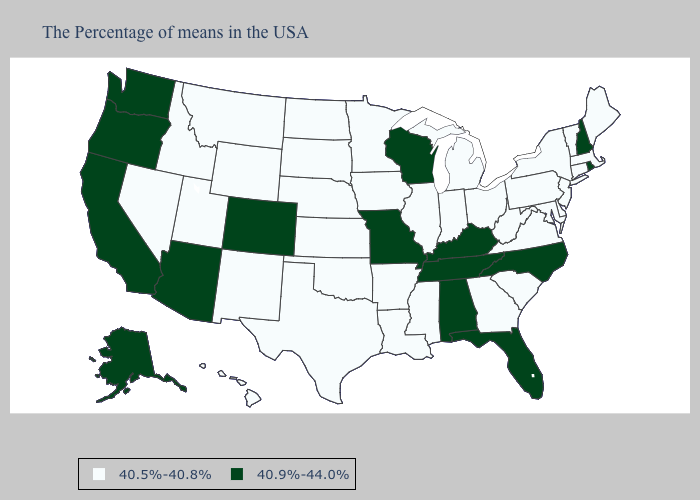What is the value of Kentucky?
Answer briefly. 40.9%-44.0%. Name the states that have a value in the range 40.5%-40.8%?
Quick response, please. Maine, Massachusetts, Vermont, Connecticut, New York, New Jersey, Delaware, Maryland, Pennsylvania, Virginia, South Carolina, West Virginia, Ohio, Georgia, Michigan, Indiana, Illinois, Mississippi, Louisiana, Arkansas, Minnesota, Iowa, Kansas, Nebraska, Oklahoma, Texas, South Dakota, North Dakota, Wyoming, New Mexico, Utah, Montana, Idaho, Nevada, Hawaii. What is the highest value in states that border New York?
Short answer required. 40.5%-40.8%. What is the lowest value in the South?
Concise answer only. 40.5%-40.8%. Among the states that border Rhode Island , which have the lowest value?
Give a very brief answer. Massachusetts, Connecticut. Among the states that border Alabama , which have the highest value?
Give a very brief answer. Florida, Tennessee. What is the value of Illinois?
Quick response, please. 40.5%-40.8%. What is the lowest value in the Northeast?
Be succinct. 40.5%-40.8%. How many symbols are there in the legend?
Be succinct. 2. Name the states that have a value in the range 40.5%-40.8%?
Concise answer only. Maine, Massachusetts, Vermont, Connecticut, New York, New Jersey, Delaware, Maryland, Pennsylvania, Virginia, South Carolina, West Virginia, Ohio, Georgia, Michigan, Indiana, Illinois, Mississippi, Louisiana, Arkansas, Minnesota, Iowa, Kansas, Nebraska, Oklahoma, Texas, South Dakota, North Dakota, Wyoming, New Mexico, Utah, Montana, Idaho, Nevada, Hawaii. Is the legend a continuous bar?
Be succinct. No. Does Wisconsin have the highest value in the MidWest?
Answer briefly. Yes. Name the states that have a value in the range 40.9%-44.0%?
Write a very short answer. Rhode Island, New Hampshire, North Carolina, Florida, Kentucky, Alabama, Tennessee, Wisconsin, Missouri, Colorado, Arizona, California, Washington, Oregon, Alaska. Among the states that border Tennessee , does North Carolina have the highest value?
Give a very brief answer. Yes. 